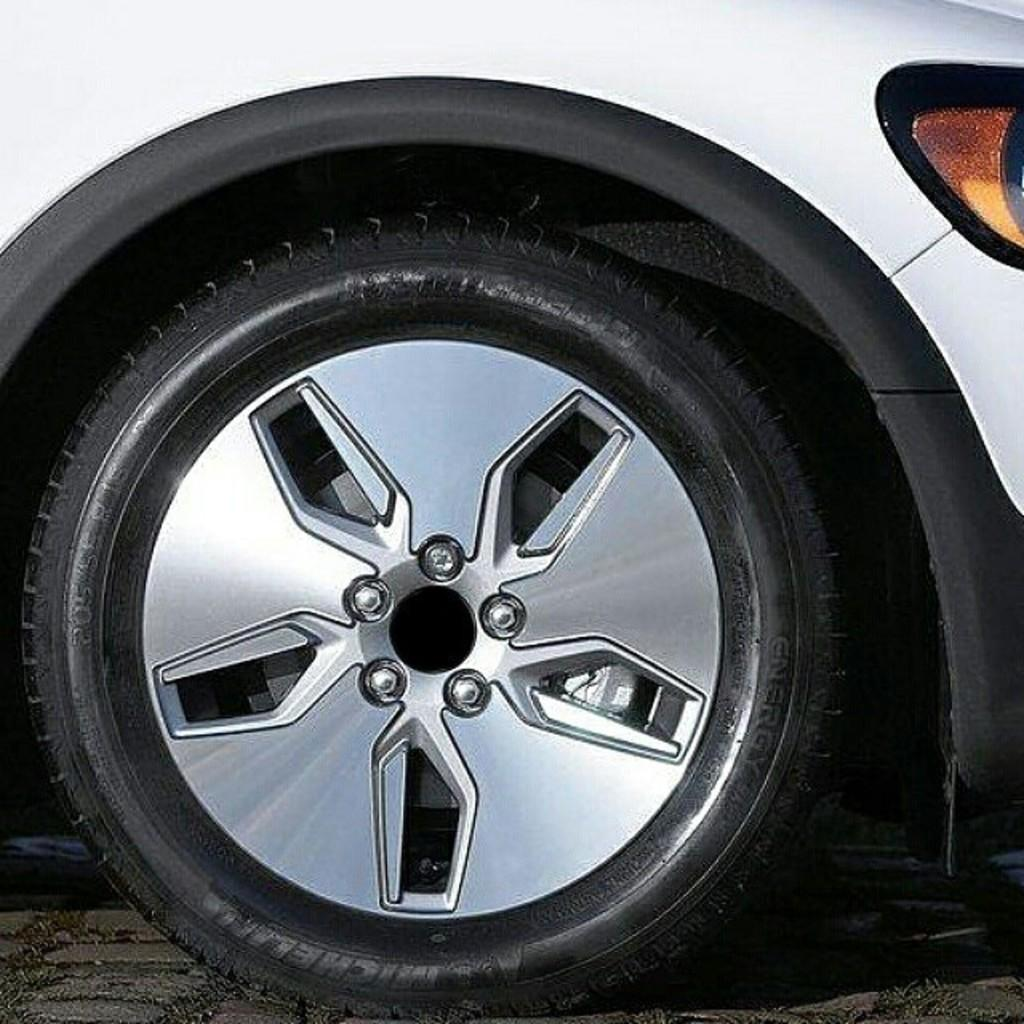What type of vehicle part is visible in the image? There is a part of a vehicle in the image. Does the vehicle part have any specific features? Yes, the vehicle part has a light. What other object related to the vehicle can be seen in the image? There is a tire on the ground in the image. Can you tell me how many bones are visible in the image? There are no bones present in the image. What type of twist can be seen in the image? There is no twist present in the image. 